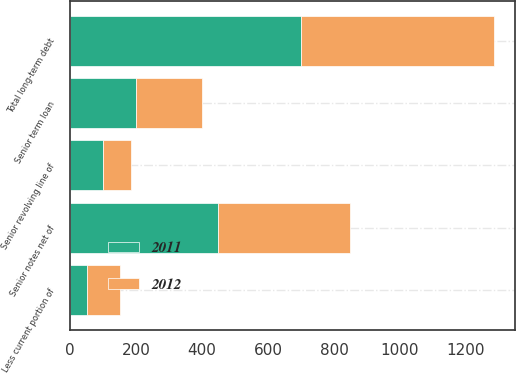Convert chart to OTSL. <chart><loc_0><loc_0><loc_500><loc_500><stacked_bar_chart><ecel><fcel>Senior revolving line of<fcel>Senior term loan<fcel>Senior notes net of<fcel>Less current portion of<fcel>Total long-term debt<nl><fcel>2012<fcel>85.8<fcel>200<fcel>399.5<fcel>100<fcel>585.3<nl><fcel>2011<fcel>99.8<fcel>200<fcel>449.4<fcel>50<fcel>699.2<nl></chart> 